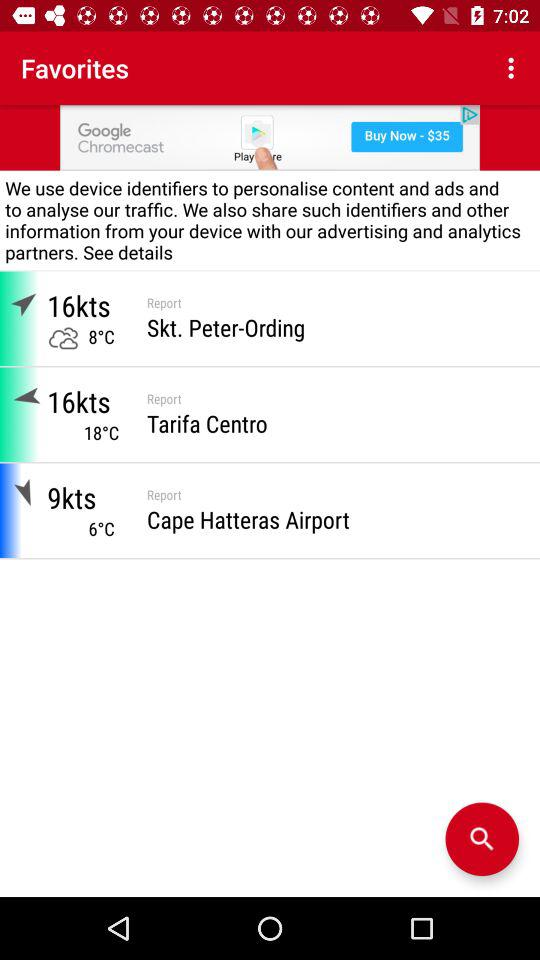How many more knots is the wind in Tarifa Centro than in Cape Hatteras Airport?
Answer the question using a single word or phrase. 7 